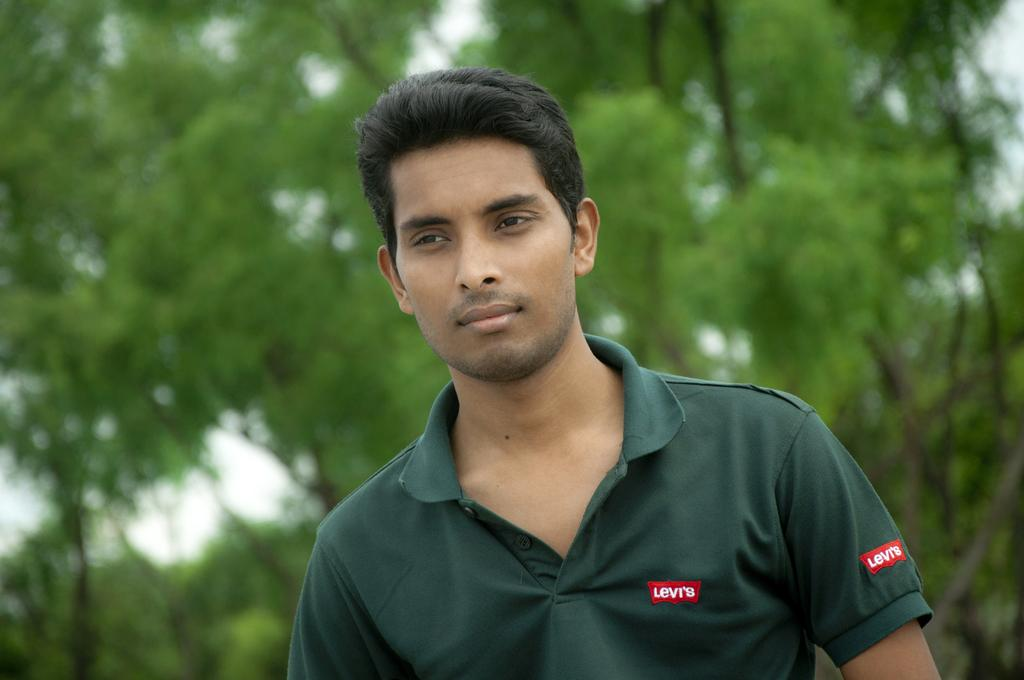Who or what is the main subject of the image? There is a person in the image. What is the person wearing? The person is wearing a green dress. Can you identify any specific details about the dress? The brand name is written on the dress. What can be seen in the background of the image? There are many trees in the background of the image. What grade does the person in the image have in their stitching abilities? There is no information about the person's stitching abilities or grades in the image. 